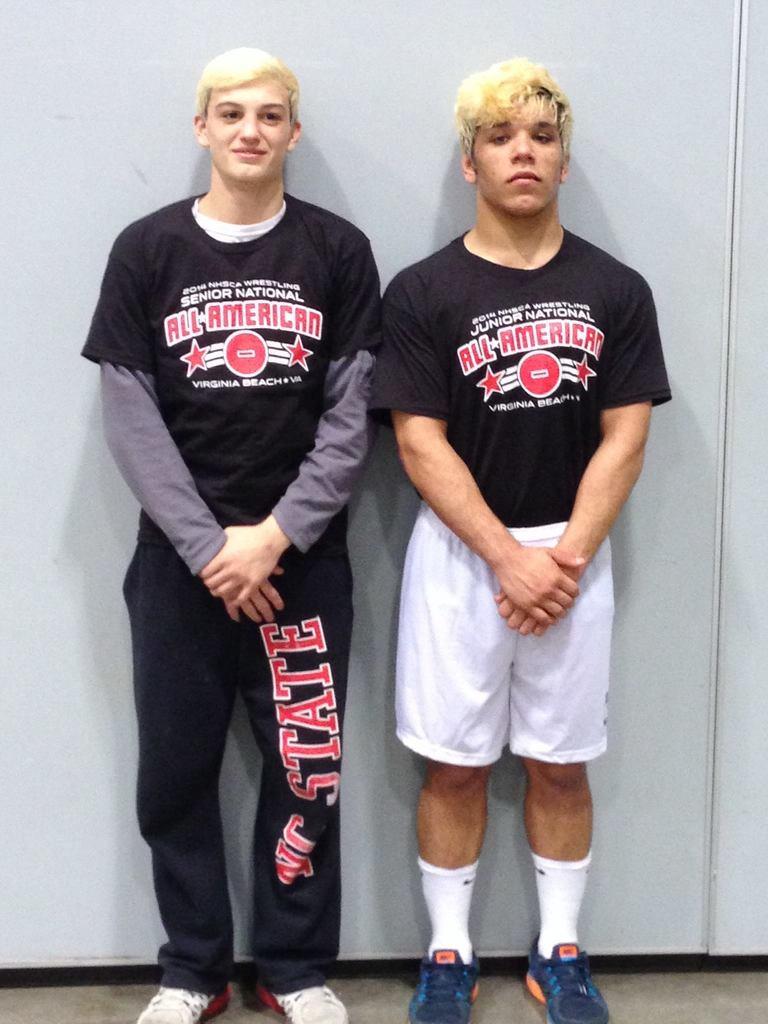What type of team are the players on?
Your answer should be very brief. All american. 